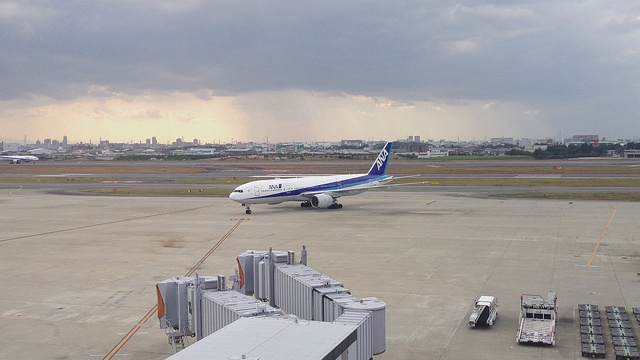Describe the objects in this image and their specific colors. I can see airplane in darkgray, lightgray, gray, and navy tones, truck in darkgray, gray, black, and lightgray tones, and truck in darkgray, black, gray, and lightgray tones in this image. 